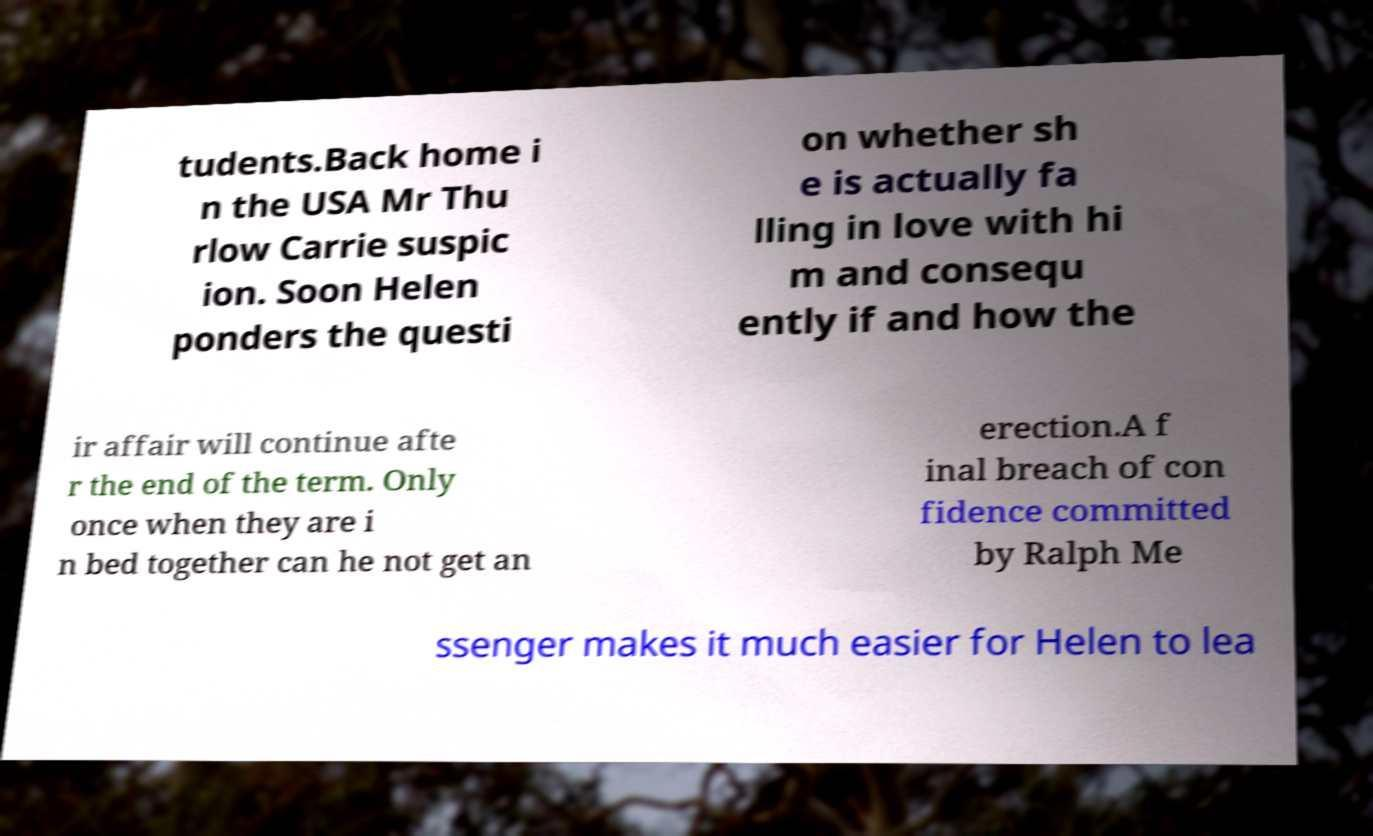Can you accurately transcribe the text from the provided image for me? tudents.Back home i n the USA Mr Thu rlow Carrie suspic ion. Soon Helen ponders the questi on whether sh e is actually fa lling in love with hi m and consequ ently if and how the ir affair will continue afte r the end of the term. Only once when they are i n bed together can he not get an erection.A f inal breach of con fidence committed by Ralph Me ssenger makes it much easier for Helen to lea 